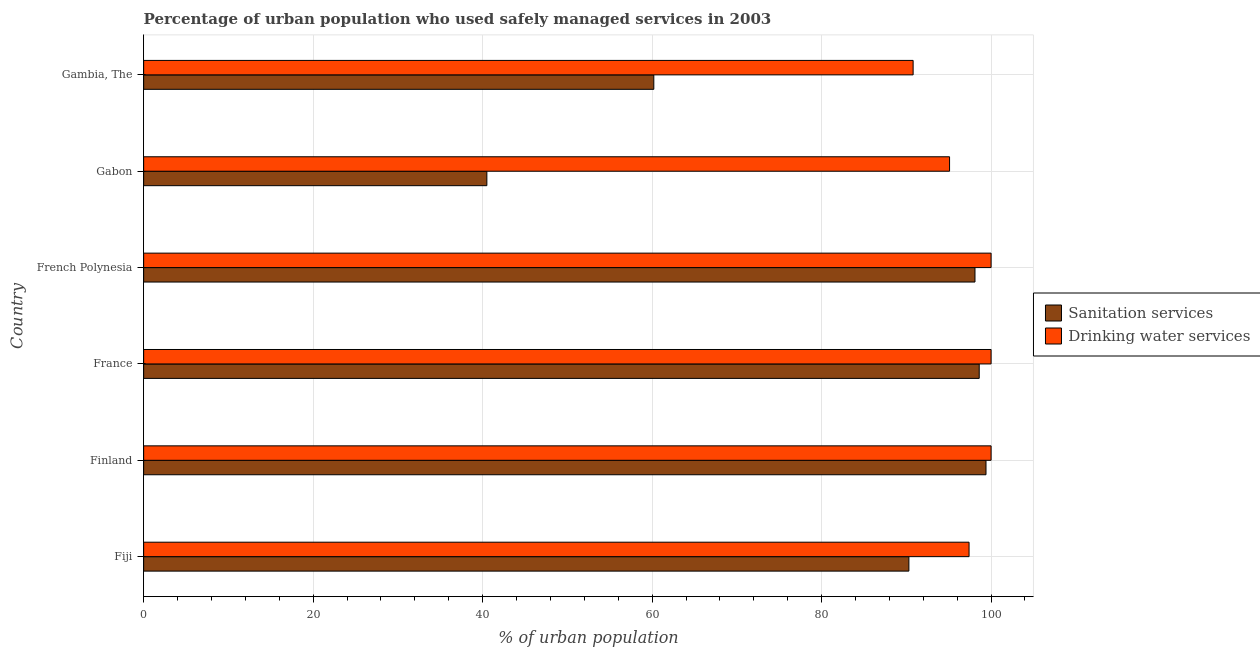Are the number of bars per tick equal to the number of legend labels?
Ensure brevity in your answer.  Yes. Are the number of bars on each tick of the Y-axis equal?
Ensure brevity in your answer.  Yes. What is the label of the 3rd group of bars from the top?
Offer a terse response. French Polynesia. In how many cases, is the number of bars for a given country not equal to the number of legend labels?
Offer a terse response. 0. Across all countries, what is the maximum percentage of urban population who used drinking water services?
Your answer should be very brief. 100. Across all countries, what is the minimum percentage of urban population who used drinking water services?
Ensure brevity in your answer.  90.8. In which country was the percentage of urban population who used sanitation services maximum?
Make the answer very short. Finland. In which country was the percentage of urban population who used drinking water services minimum?
Provide a succinct answer. Gambia, The. What is the total percentage of urban population who used sanitation services in the graph?
Make the answer very short. 487.1. What is the difference between the percentage of urban population who used sanitation services in France and that in Gabon?
Provide a succinct answer. 58.1. What is the difference between the percentage of urban population who used sanitation services in Gambia, The and the percentage of urban population who used drinking water services in French Polynesia?
Give a very brief answer. -39.8. What is the average percentage of urban population who used sanitation services per country?
Make the answer very short. 81.18. What is the difference between the percentage of urban population who used sanitation services and percentage of urban population who used drinking water services in Fiji?
Your answer should be compact. -7.1. In how many countries, is the percentage of urban population who used sanitation services greater than 100 %?
Give a very brief answer. 0. What is the ratio of the percentage of urban population who used drinking water services in Fiji to that in Gambia, The?
Give a very brief answer. 1.07. Is the percentage of urban population who used drinking water services in Finland less than that in Gambia, The?
Provide a succinct answer. No. What is the difference between the highest and the lowest percentage of urban population who used sanitation services?
Give a very brief answer. 58.9. Is the sum of the percentage of urban population who used drinking water services in France and Gambia, The greater than the maximum percentage of urban population who used sanitation services across all countries?
Make the answer very short. Yes. What does the 2nd bar from the top in Gabon represents?
Provide a short and direct response. Sanitation services. What does the 1st bar from the bottom in Gambia, The represents?
Ensure brevity in your answer.  Sanitation services. How many bars are there?
Offer a very short reply. 12. Does the graph contain grids?
Give a very brief answer. Yes. How many legend labels are there?
Provide a succinct answer. 2. How are the legend labels stacked?
Your answer should be very brief. Vertical. What is the title of the graph?
Provide a succinct answer. Percentage of urban population who used safely managed services in 2003. Does "All education staff compensation" appear as one of the legend labels in the graph?
Offer a very short reply. No. What is the label or title of the X-axis?
Your answer should be very brief. % of urban population. What is the label or title of the Y-axis?
Keep it short and to the point. Country. What is the % of urban population of Sanitation services in Fiji?
Your response must be concise. 90.3. What is the % of urban population of Drinking water services in Fiji?
Provide a short and direct response. 97.4. What is the % of urban population in Sanitation services in Finland?
Keep it short and to the point. 99.4. What is the % of urban population in Drinking water services in Finland?
Keep it short and to the point. 100. What is the % of urban population in Sanitation services in France?
Keep it short and to the point. 98.6. What is the % of urban population in Drinking water services in France?
Give a very brief answer. 100. What is the % of urban population of Sanitation services in French Polynesia?
Give a very brief answer. 98.1. What is the % of urban population in Sanitation services in Gabon?
Ensure brevity in your answer.  40.5. What is the % of urban population of Drinking water services in Gabon?
Provide a short and direct response. 95.1. What is the % of urban population of Sanitation services in Gambia, The?
Offer a very short reply. 60.2. What is the % of urban population of Drinking water services in Gambia, The?
Provide a short and direct response. 90.8. Across all countries, what is the maximum % of urban population in Sanitation services?
Offer a very short reply. 99.4. Across all countries, what is the minimum % of urban population in Sanitation services?
Make the answer very short. 40.5. Across all countries, what is the minimum % of urban population of Drinking water services?
Make the answer very short. 90.8. What is the total % of urban population of Sanitation services in the graph?
Ensure brevity in your answer.  487.1. What is the total % of urban population of Drinking water services in the graph?
Provide a short and direct response. 583.3. What is the difference between the % of urban population of Sanitation services in Fiji and that in France?
Your answer should be very brief. -8.3. What is the difference between the % of urban population in Drinking water services in Fiji and that in France?
Provide a succinct answer. -2.6. What is the difference between the % of urban population in Drinking water services in Fiji and that in French Polynesia?
Keep it short and to the point. -2.6. What is the difference between the % of urban population of Sanitation services in Fiji and that in Gabon?
Your response must be concise. 49.8. What is the difference between the % of urban population in Drinking water services in Fiji and that in Gabon?
Make the answer very short. 2.3. What is the difference between the % of urban population of Sanitation services in Fiji and that in Gambia, The?
Your response must be concise. 30.1. What is the difference between the % of urban population in Drinking water services in Fiji and that in Gambia, The?
Offer a very short reply. 6.6. What is the difference between the % of urban population of Sanitation services in Finland and that in France?
Your response must be concise. 0.8. What is the difference between the % of urban population in Drinking water services in Finland and that in French Polynesia?
Your answer should be compact. 0. What is the difference between the % of urban population of Sanitation services in Finland and that in Gabon?
Ensure brevity in your answer.  58.9. What is the difference between the % of urban population of Drinking water services in Finland and that in Gabon?
Keep it short and to the point. 4.9. What is the difference between the % of urban population in Sanitation services in Finland and that in Gambia, The?
Your answer should be very brief. 39.2. What is the difference between the % of urban population of Sanitation services in France and that in French Polynesia?
Keep it short and to the point. 0.5. What is the difference between the % of urban population in Drinking water services in France and that in French Polynesia?
Offer a very short reply. 0. What is the difference between the % of urban population of Sanitation services in France and that in Gabon?
Offer a terse response. 58.1. What is the difference between the % of urban population in Sanitation services in France and that in Gambia, The?
Ensure brevity in your answer.  38.4. What is the difference between the % of urban population of Drinking water services in France and that in Gambia, The?
Keep it short and to the point. 9.2. What is the difference between the % of urban population of Sanitation services in French Polynesia and that in Gabon?
Provide a succinct answer. 57.6. What is the difference between the % of urban population of Drinking water services in French Polynesia and that in Gabon?
Offer a terse response. 4.9. What is the difference between the % of urban population of Sanitation services in French Polynesia and that in Gambia, The?
Offer a very short reply. 37.9. What is the difference between the % of urban population in Drinking water services in French Polynesia and that in Gambia, The?
Your answer should be very brief. 9.2. What is the difference between the % of urban population in Sanitation services in Gabon and that in Gambia, The?
Offer a terse response. -19.7. What is the difference between the % of urban population of Drinking water services in Gabon and that in Gambia, The?
Offer a terse response. 4.3. What is the difference between the % of urban population of Sanitation services in Fiji and the % of urban population of Drinking water services in French Polynesia?
Keep it short and to the point. -9.7. What is the difference between the % of urban population of Sanitation services in Fiji and the % of urban population of Drinking water services in Gabon?
Your answer should be compact. -4.8. What is the difference between the % of urban population in Sanitation services in Finland and the % of urban population in Drinking water services in French Polynesia?
Provide a succinct answer. -0.6. What is the difference between the % of urban population of Sanitation services in Finland and the % of urban population of Drinking water services in Gambia, The?
Your answer should be compact. 8.6. What is the difference between the % of urban population in Sanitation services in France and the % of urban population in Drinking water services in Gabon?
Make the answer very short. 3.5. What is the difference between the % of urban population of Sanitation services in French Polynesia and the % of urban population of Drinking water services in Gabon?
Provide a succinct answer. 3. What is the difference between the % of urban population of Sanitation services in Gabon and the % of urban population of Drinking water services in Gambia, The?
Your answer should be compact. -50.3. What is the average % of urban population of Sanitation services per country?
Your response must be concise. 81.18. What is the average % of urban population of Drinking water services per country?
Your answer should be very brief. 97.22. What is the difference between the % of urban population of Sanitation services and % of urban population of Drinking water services in Finland?
Give a very brief answer. -0.6. What is the difference between the % of urban population of Sanitation services and % of urban population of Drinking water services in France?
Keep it short and to the point. -1.4. What is the difference between the % of urban population of Sanitation services and % of urban population of Drinking water services in Gabon?
Provide a short and direct response. -54.6. What is the difference between the % of urban population of Sanitation services and % of urban population of Drinking water services in Gambia, The?
Your answer should be compact. -30.6. What is the ratio of the % of urban population in Sanitation services in Fiji to that in Finland?
Your answer should be very brief. 0.91. What is the ratio of the % of urban population in Sanitation services in Fiji to that in France?
Offer a terse response. 0.92. What is the ratio of the % of urban population of Drinking water services in Fiji to that in France?
Keep it short and to the point. 0.97. What is the ratio of the % of urban population of Sanitation services in Fiji to that in French Polynesia?
Your answer should be very brief. 0.92. What is the ratio of the % of urban population of Sanitation services in Fiji to that in Gabon?
Offer a terse response. 2.23. What is the ratio of the % of urban population in Drinking water services in Fiji to that in Gabon?
Your response must be concise. 1.02. What is the ratio of the % of urban population of Sanitation services in Fiji to that in Gambia, The?
Ensure brevity in your answer.  1.5. What is the ratio of the % of urban population in Drinking water services in Fiji to that in Gambia, The?
Offer a very short reply. 1.07. What is the ratio of the % of urban population of Sanitation services in Finland to that in France?
Provide a succinct answer. 1.01. What is the ratio of the % of urban population in Drinking water services in Finland to that in France?
Provide a short and direct response. 1. What is the ratio of the % of urban population in Sanitation services in Finland to that in French Polynesia?
Your answer should be very brief. 1.01. What is the ratio of the % of urban population in Sanitation services in Finland to that in Gabon?
Offer a terse response. 2.45. What is the ratio of the % of urban population in Drinking water services in Finland to that in Gabon?
Give a very brief answer. 1.05. What is the ratio of the % of urban population in Sanitation services in Finland to that in Gambia, The?
Your answer should be very brief. 1.65. What is the ratio of the % of urban population of Drinking water services in Finland to that in Gambia, The?
Provide a short and direct response. 1.1. What is the ratio of the % of urban population of Sanitation services in France to that in French Polynesia?
Ensure brevity in your answer.  1.01. What is the ratio of the % of urban population in Drinking water services in France to that in French Polynesia?
Keep it short and to the point. 1. What is the ratio of the % of urban population of Sanitation services in France to that in Gabon?
Offer a very short reply. 2.43. What is the ratio of the % of urban population in Drinking water services in France to that in Gabon?
Provide a succinct answer. 1.05. What is the ratio of the % of urban population of Sanitation services in France to that in Gambia, The?
Ensure brevity in your answer.  1.64. What is the ratio of the % of urban population in Drinking water services in France to that in Gambia, The?
Ensure brevity in your answer.  1.1. What is the ratio of the % of urban population of Sanitation services in French Polynesia to that in Gabon?
Ensure brevity in your answer.  2.42. What is the ratio of the % of urban population in Drinking water services in French Polynesia to that in Gabon?
Provide a short and direct response. 1.05. What is the ratio of the % of urban population in Sanitation services in French Polynesia to that in Gambia, The?
Provide a succinct answer. 1.63. What is the ratio of the % of urban population of Drinking water services in French Polynesia to that in Gambia, The?
Your answer should be compact. 1.1. What is the ratio of the % of urban population in Sanitation services in Gabon to that in Gambia, The?
Your answer should be compact. 0.67. What is the ratio of the % of urban population in Drinking water services in Gabon to that in Gambia, The?
Make the answer very short. 1.05. What is the difference between the highest and the lowest % of urban population in Sanitation services?
Give a very brief answer. 58.9. 